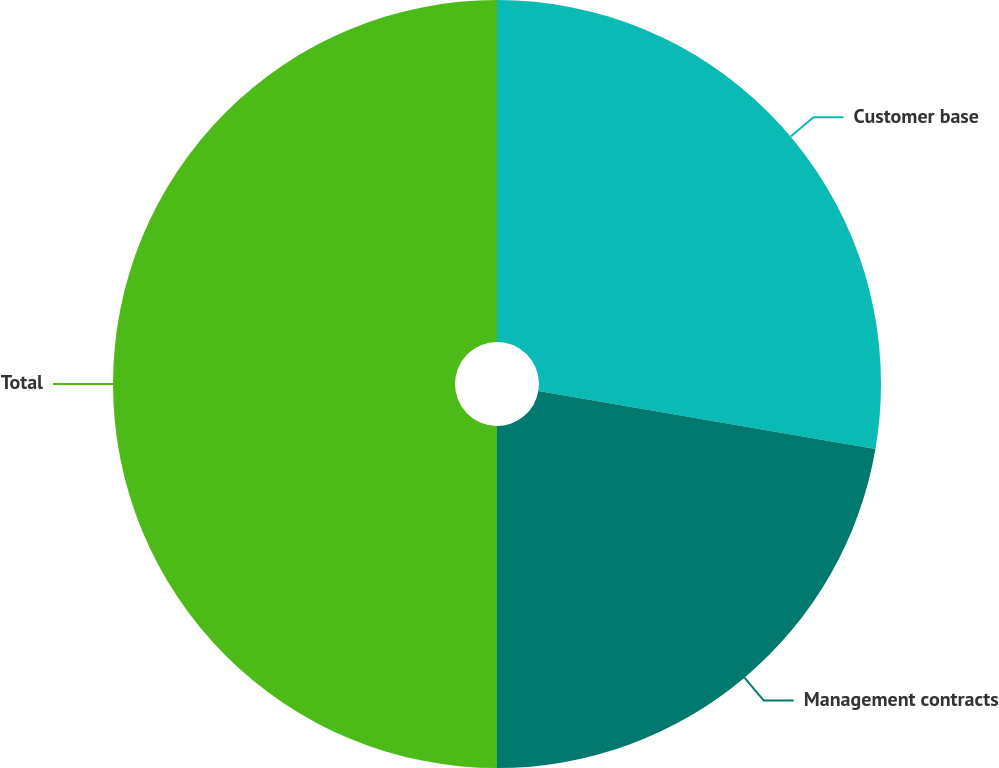Convert chart to OTSL. <chart><loc_0><loc_0><loc_500><loc_500><pie_chart><fcel>Customer base<fcel>Management contracts<fcel>Total<nl><fcel>27.71%<fcel>22.29%<fcel>50.0%<nl></chart> 